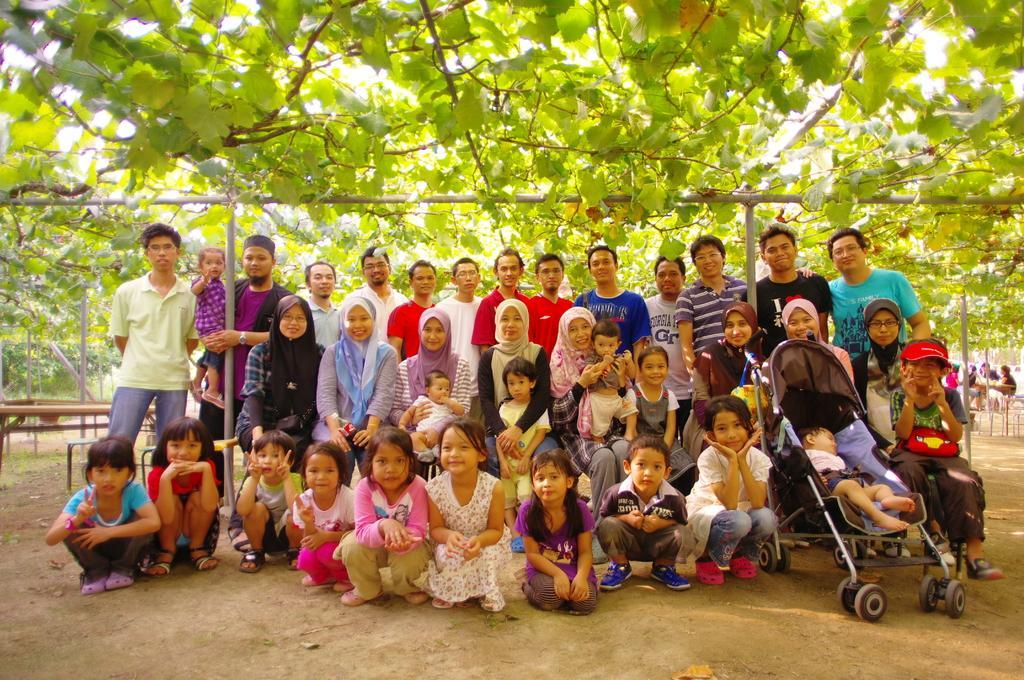Could you give a brief overview of what you see in this image? In the image we can see there are many people around, we can see they are standing and others are sitting, they are wearing clothes and some of them are wearing shoes. Here we can baby cart, trees and the bench 